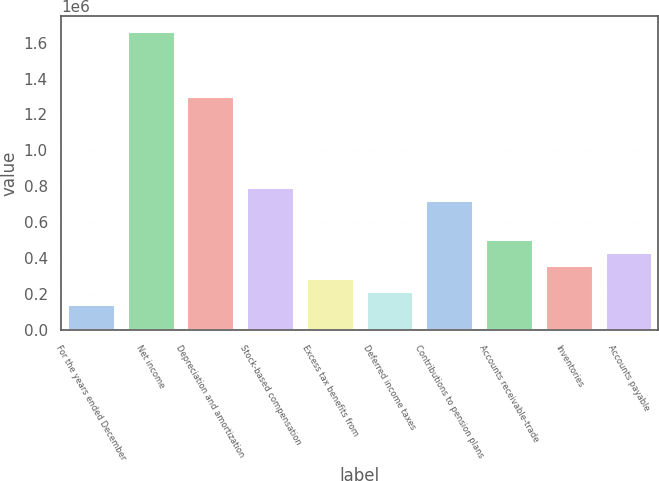Convert chart to OTSL. <chart><loc_0><loc_0><loc_500><loc_500><bar_chart><fcel>For the years ended December<fcel>Net income<fcel>Depreciation and amortization<fcel>Stock-based compensation<fcel>Excess tax benefits from<fcel>Deferred income taxes<fcel>Contributions to pension plans<fcel>Accounts receivable-trade<fcel>Inventories<fcel>Accounts payable<nl><fcel>144826<fcel>1.66304e+06<fcel>1.30156e+06<fcel>795489<fcel>289418<fcel>217122<fcel>723193<fcel>506305<fcel>361714<fcel>434009<nl></chart> 